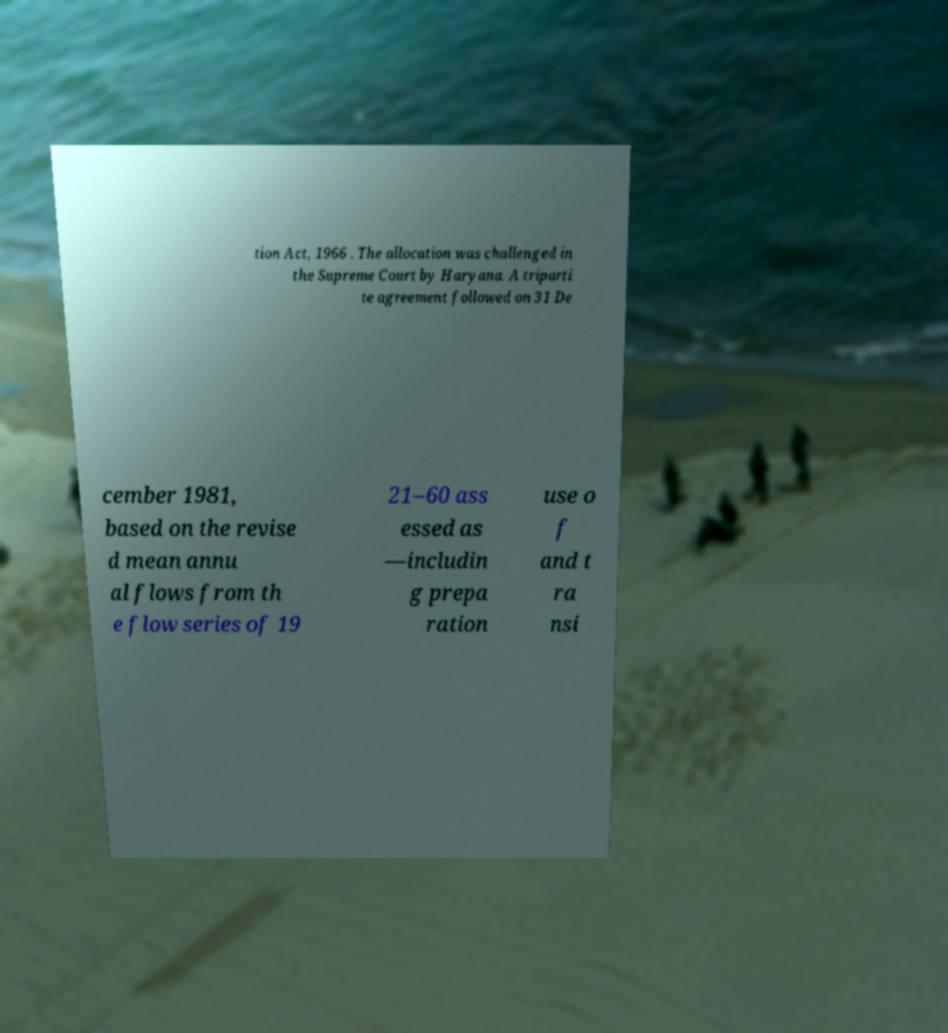There's text embedded in this image that I need extracted. Can you transcribe it verbatim? tion Act, 1966 . The allocation was challenged in the Supreme Court by Haryana. A triparti te agreement followed on 31 De cember 1981, based on the revise d mean annu al flows from th e flow series of 19 21–60 ass essed as —includin g prepa ration use o f and t ra nsi 